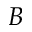<formula> <loc_0><loc_0><loc_500><loc_500>B</formula> 